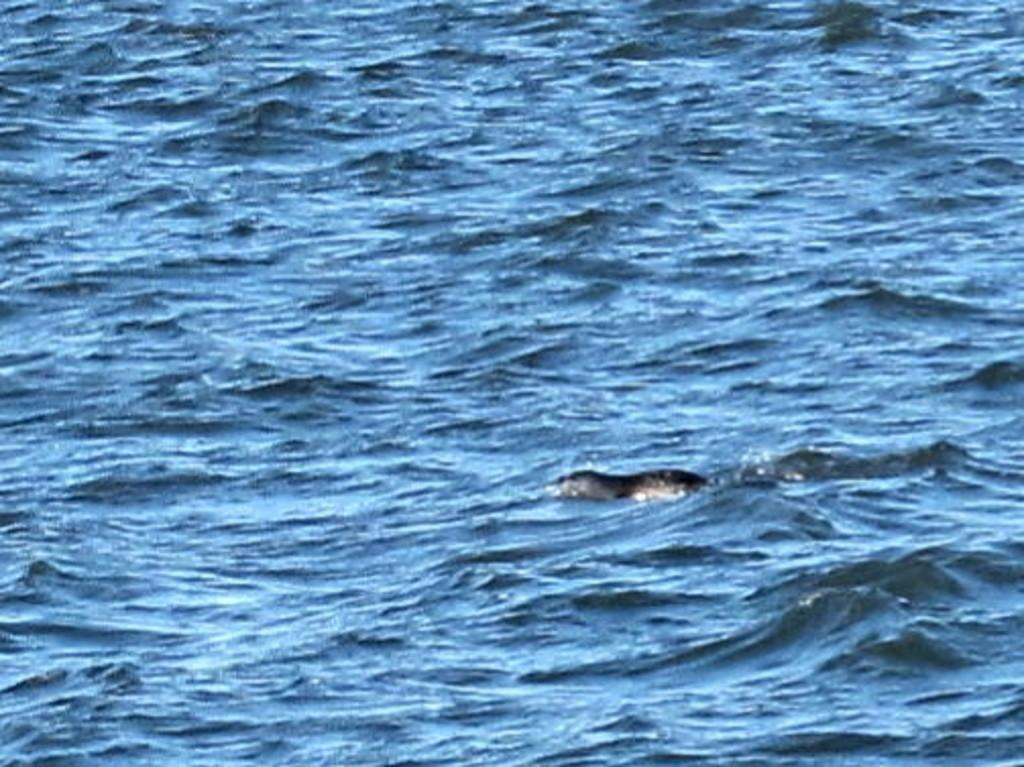What is the main subject of the image? There is an animal in the water in the image. Can you describe the animal's location in the image? The animal is in the water. What type of environment is depicted in the image? The image shows a water environment. What type of jeans is the fish wearing in the image? There is no fish present in the image, and therefore no fish wearing jeans. 